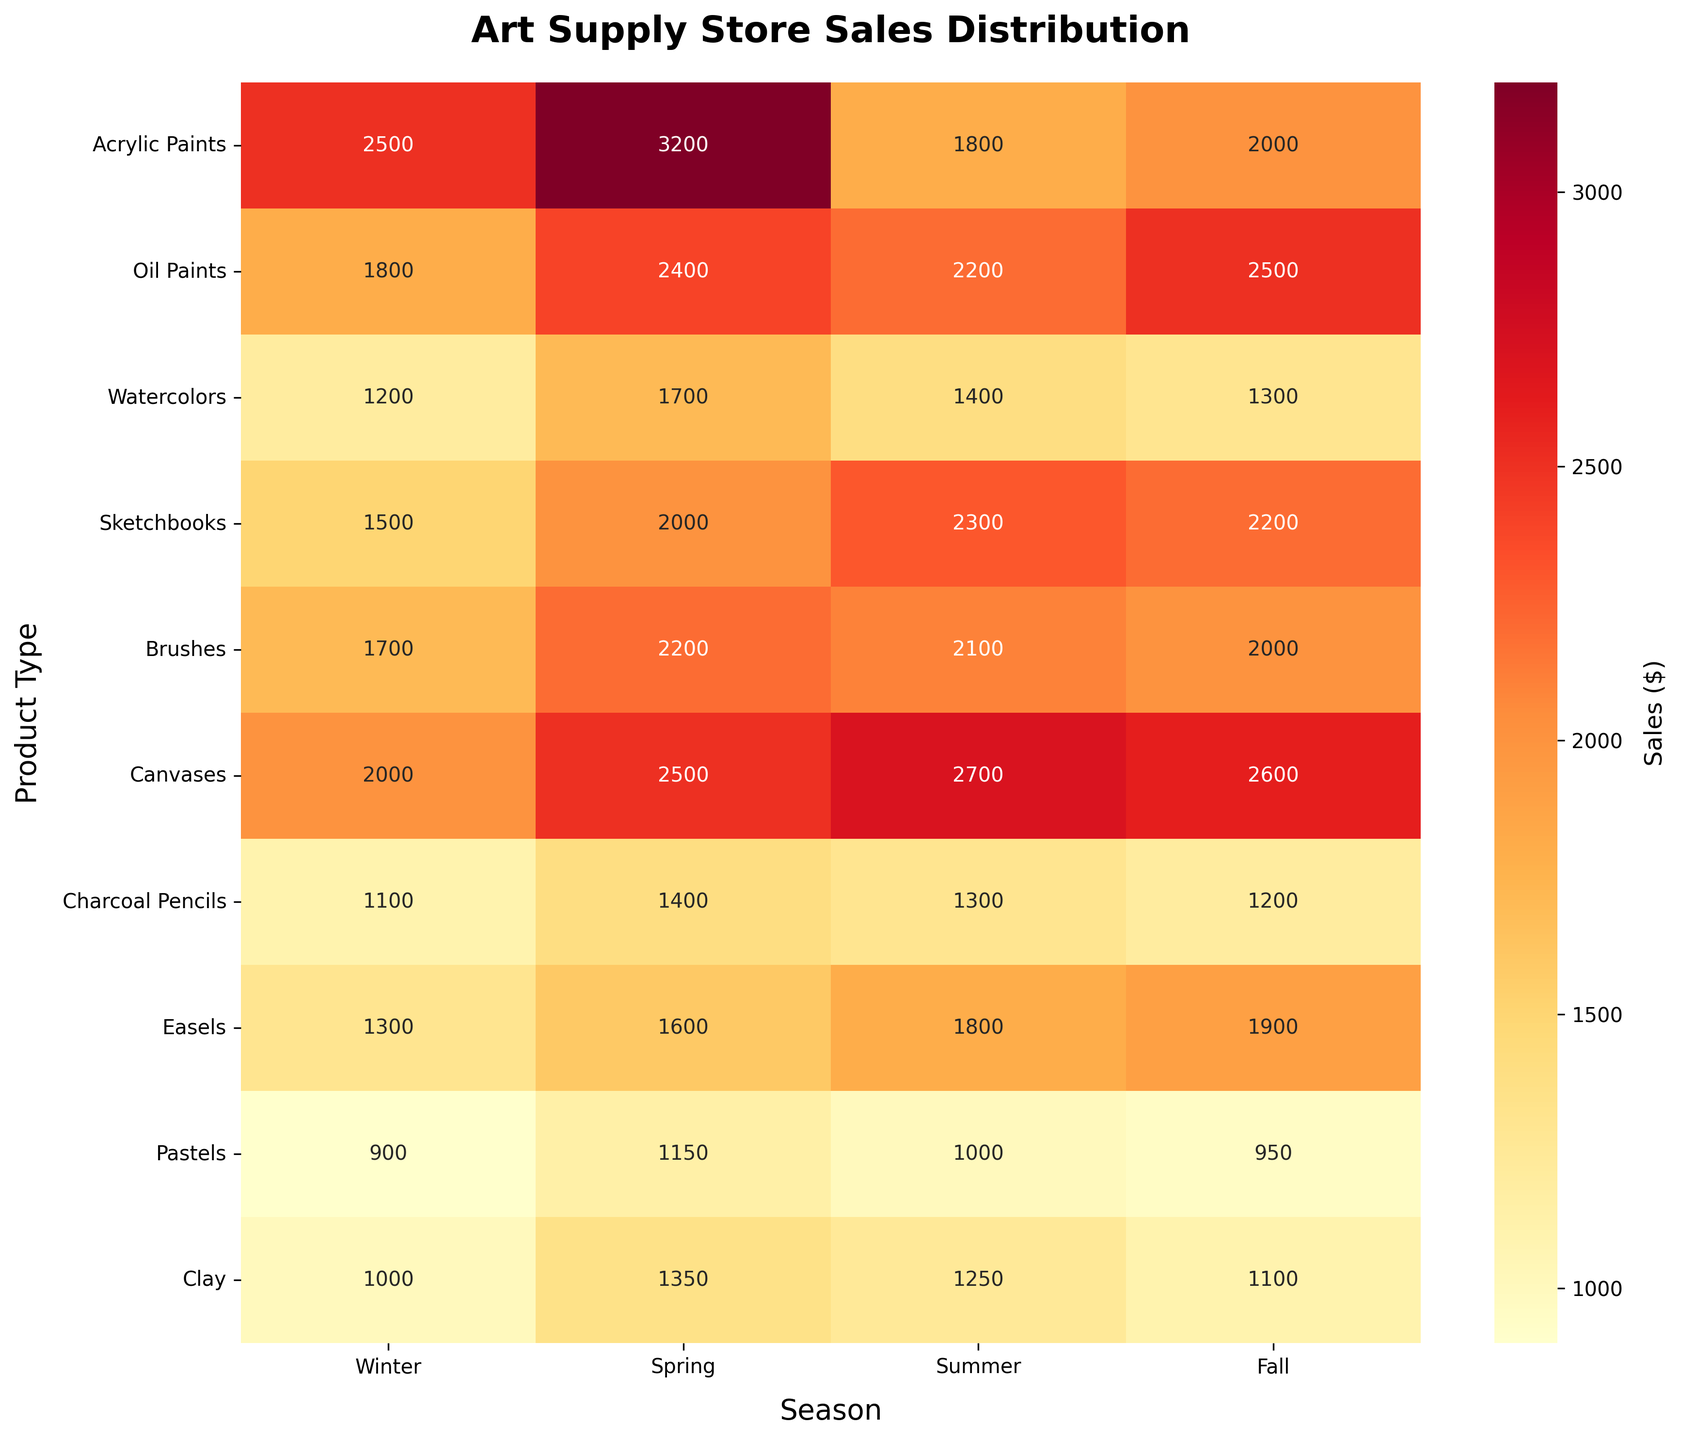What is the highest sales figure for Acrylic Paints? The highest sales figure for Acrylic Paints can be identified by looking at its row in the heatmap and finding the maximum value. The values for Acrylic Paints across Winter, Spring, Summer, and Fall are 2500, 3200, 1800, and 2000, respectively. Among these, 3200 is the highest.
Answer: 3200 Which season has the lowest sales for Charcoal Pencils? To determine the season with the lowest sales for Charcoal Pencils, identify the minimum value in the Charcoal Pencils row. The sales figures are 1100 in Winter, 1400 in Spring, 1300 in Summer, and 1200 in Fall. The lowest value is 1100, which is in Winter.
Answer: Winter What is the average sales figure for Canvases across all seasons? Sum up all the sales figures for Canvases and divide by the number of seasons. The sales figures are 2000, 2500, 2700, and 2600. Total sales = 2000 + 2500 + 2700 + 2600 = 9800. Average sales = 9800 / 4 = 2450.
Answer: 2450 Which product type has the highest overall sales in Spring? Check the sales figures for all product types in the Spring column. The figures are 3200 (Acrylic Paints), 2400 (Oil Paints), 1700 (Watercolors), 2000 (Sketchbooks), 2200 (Brushes), 2500 (Canvases), 1400 (Charcoal Pencils), 1600 (Easels), 1150 (Pastels), and 1350 (Clay). The highest value is 3200 for Acrylic Paints.
Answer: Acrylic Paints Is Oil Paints' sales greater in Fall or Summer? Compare the sales figures for Oil Paints in Summer and Fall. The figures are 2200 in Summer and 2500 in Fall. Since 2500 is greater than 2200, Oil Paints have higher sales in Fall.
Answer: Fall What is the total sales for Brushes across all seasons? Sum up the sales figures for Brushes in Winter, Spring, Summer, and Fall. The figures are 1700, 2200, 2100, and 2000. Total sales = 1700 + 2200 + 2100 + 2000 = 8000.
Answer: 8000 Which product has the lowest sales in Summer? Check the sales figures for all products in the Summer column. The figures are 1800 (Acrylic Paints), 2200 (Oil Paints), 1400 (Watercolors), 2300 (Sketchbooks), 2100 (Brushes), 2700 (Canvases), 1300 (Charcoal Pencils), 1800 (Easels), 1000 (Pastels), and 1250 (Clay). The lowest value is 1000 for Pastels.
Answer: Pastels Considering Winter sales, which two products have the closest sales figures? Compare the sales figures for all products in Winter: 2500 (Acrylic Paints), 1800 (Oil Paints), 1200 (Watercolors), 1500 (Sketchbooks), 1700 (Brushes), 2000 (Canvases), 1100 (Charcoal Pencils), 1300 (Easels), 900 (Pastels), 1000 (Clay). Sketchbooks (1500) and Brushes (1700) are the closest, with a difference of 200.
Answer: Sketchbooks and Brushes How much more were the Spring sales of Watercolors compared to the Fall sales? Subtract the Fall sales figure of Watercolors from the Spring sales figure. The sales figures are 1700 (Spring) and 1300 (Fall). Difference = 1700 - 1300 = 400.
Answer: 400 